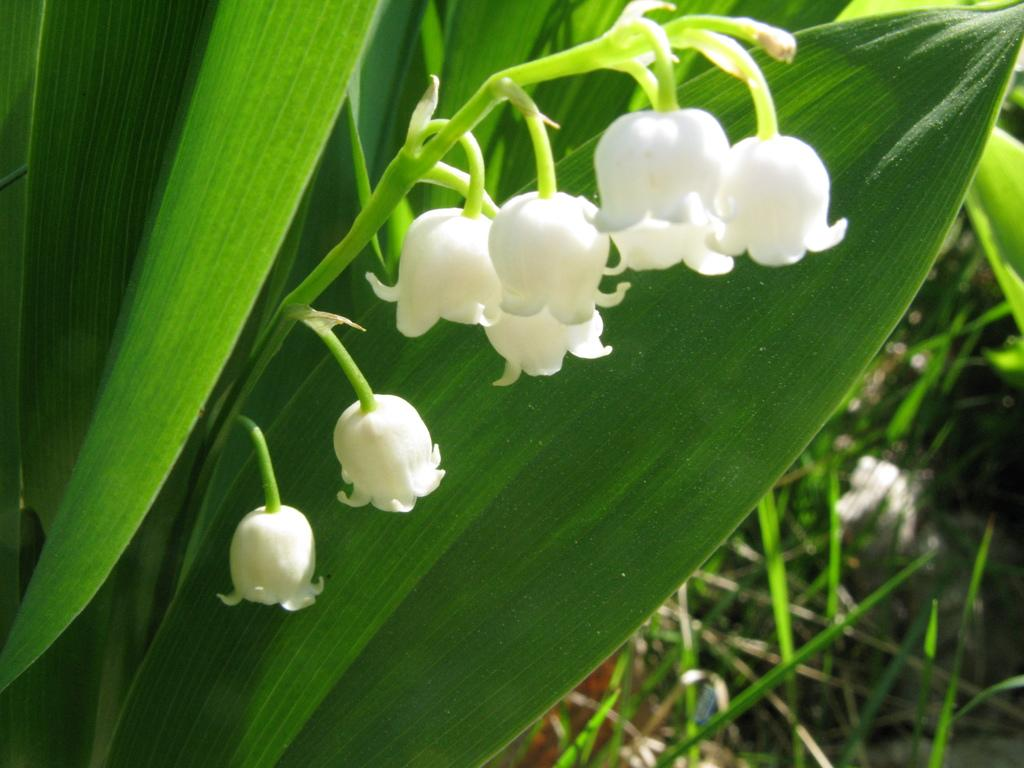What type of living organisms can be seen in the image? Flowers and plants can be seen in the image. What color are the flowers in the image? The flowers in the image are white in color. What type of regret can be seen in the image? There is no regret present in the image; it features flowers and plants. What type of ground is visible in the image? The provided facts do not mention the ground, so it cannot be determined from the image. 